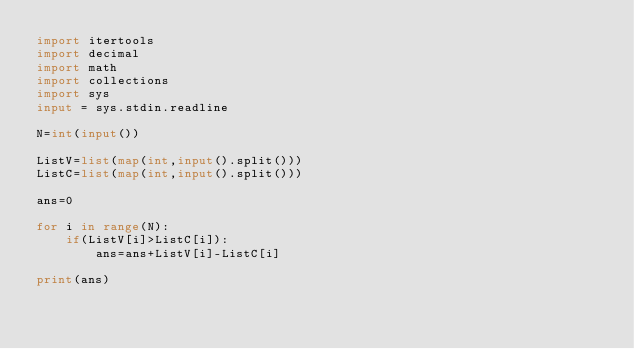<code> <loc_0><loc_0><loc_500><loc_500><_Python_>import itertools
import decimal
import math
import collections
import sys
input = sys.stdin.readline

N=int(input())

ListV=list(map(int,input().split()))
ListC=list(map(int,input().split()))

ans=0

for i in range(N):
    if(ListV[i]>ListC[i]):
        ans=ans+ListV[i]-ListC[i]

print(ans)</code> 